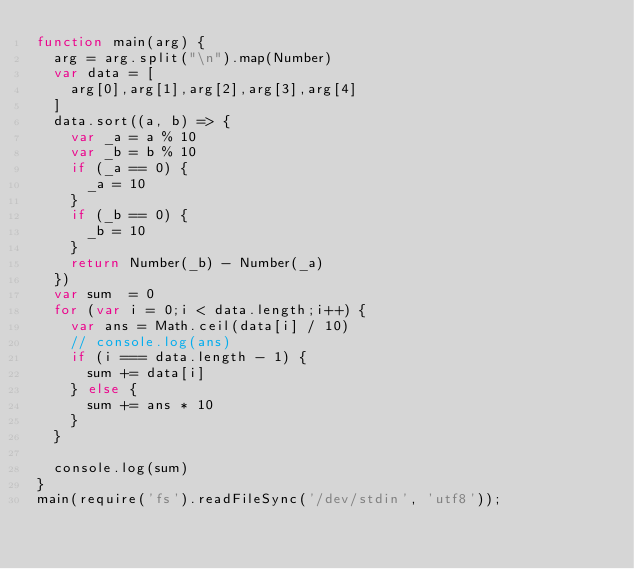<code> <loc_0><loc_0><loc_500><loc_500><_JavaScript_>function main(arg) {
	arg = arg.split("\n").map(Number)
	var data = [
		arg[0],arg[1],arg[2],arg[3],arg[4]
	]
	data.sort((a, b) => {
		var _a = a % 10
		var _b = b % 10
		if (_a == 0) {
			_a = 10
		}
		if (_b == 0) {
			_b = 10
		}
		return Number(_b) - Number(_a)
	})
	var sum  = 0
	for (var i = 0;i < data.length;i++) {
		var ans = Math.ceil(data[i] / 10)
		// console.log(ans)
		if (i === data.length - 1) {
			sum += data[i]
		} else {
			sum += ans * 10
		}
	}

	console.log(sum)
}
main(require('fs').readFileSync('/dev/stdin', 'utf8'));</code> 